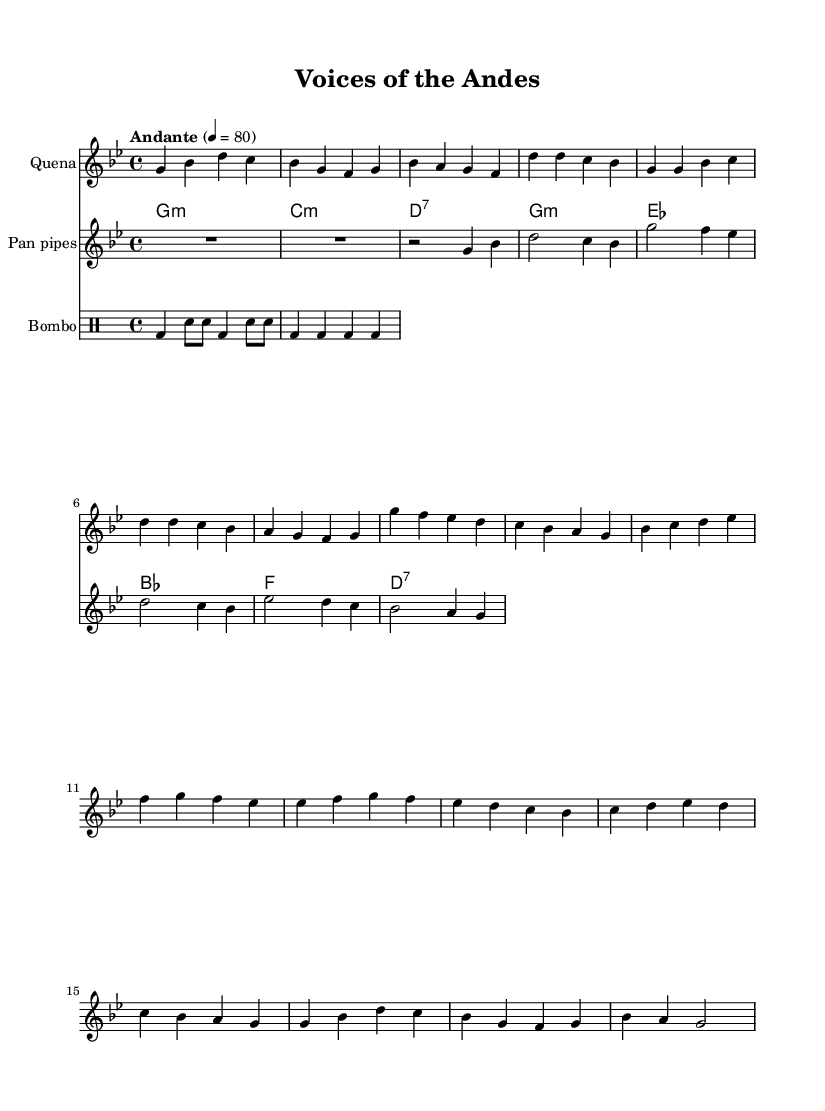What is the key signature of this music? The key signature is identified by the number of sharps or flats indicated at the beginning of the music staff. In this case, there are two flats, which indicates that the key is G minor.
Answer: G minor What is the time signature of the piece? The time signature, shown as a fraction at the beginning of the music, indicates the number of beats per measure and the note value that represents one beat. Here, it is 4/4, meaning there are four beats in each measure, and the quarter note gets one beat.
Answer: 4/4 What is the tempo marking of this piece? The tempo marking is usually found under the title or at the beginning of the music. It indicates the speed of the piece. In this case, it is marked as "Andante" with a tempo of 80 beats per minute, indicating a moderate pace.
Answer: Andante 80 How many instruments are featured in the score? The score shows multiple staffs, each representing a different instrument. By observing these, we can count three instruments: the Quena, Pan pipes, and Bombo, confirming that there are three distinct instruments present in the score.
Answer: Three What kind of rhythm does the Bombo section consist of? By analyzing the notation in the Bombo part, we note that it consists primarily of quarter notes and eighth notes, indicating a percussive rhythm typical for a Bombo, emphasizing the beat and providing a foundation for the other instruments.
Answer: Percussive rhythm Which instruments are classified as melody instruments in this score? Melodic instruments typically carry the main theme or melody. In this score, the Quena and Pan pipes serve as the melodic instruments, playing the main melodies, while the Bombo functions as a rhythmic accompaniment.
Answer: Quena and Pan pipes What cultural themes can be inferred from the instrumentation used in the piece? The choice of instruments like the Quena, Charango, and Pan pipes suggests a strong connection to Andean folk traditions. These instruments are rooted in indigenous culture, which often incorporates themes of nature and biodiversity, indicative of the cultural perspective on environmental conservation and rights.
Answer: Indigenous culture and biodiversity 